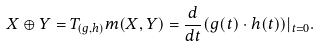<formula> <loc_0><loc_0><loc_500><loc_500>X \oplus Y = T _ { ( g , h ) } m ( X , Y ) = \frac { d } { d t } ( g ( t ) \cdot h ( t ) ) | _ { t = 0 } .</formula> 